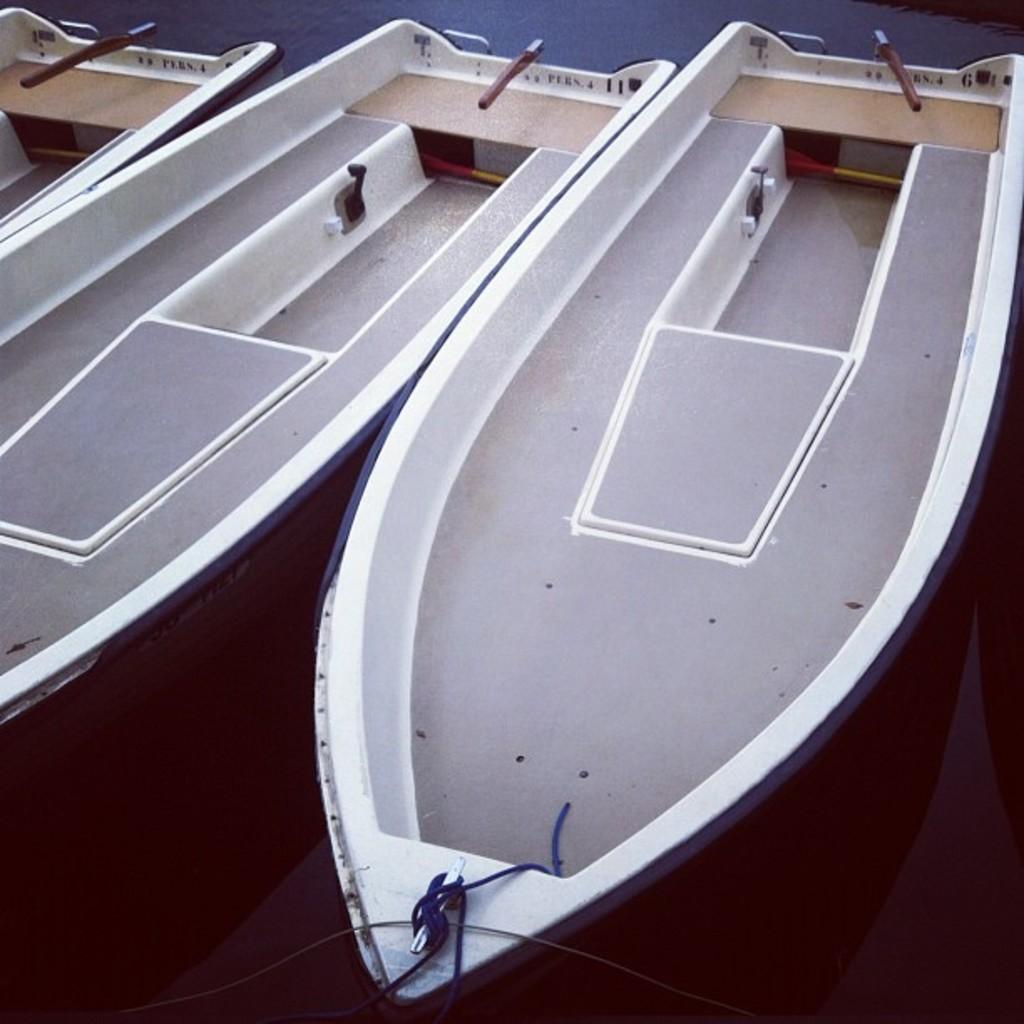Could you give a brief overview of what you see in this image? In this image there are three boats as we can see in middle of this image and there is a rope are tied to it at bottom of this image. 